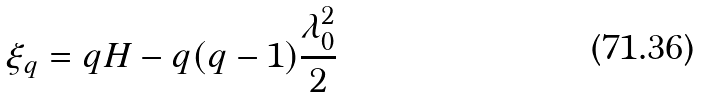<formula> <loc_0><loc_0><loc_500><loc_500>\xi _ { q } = q H - q ( q - 1 ) \frac { \lambda _ { 0 } ^ { 2 } } { 2 }</formula> 